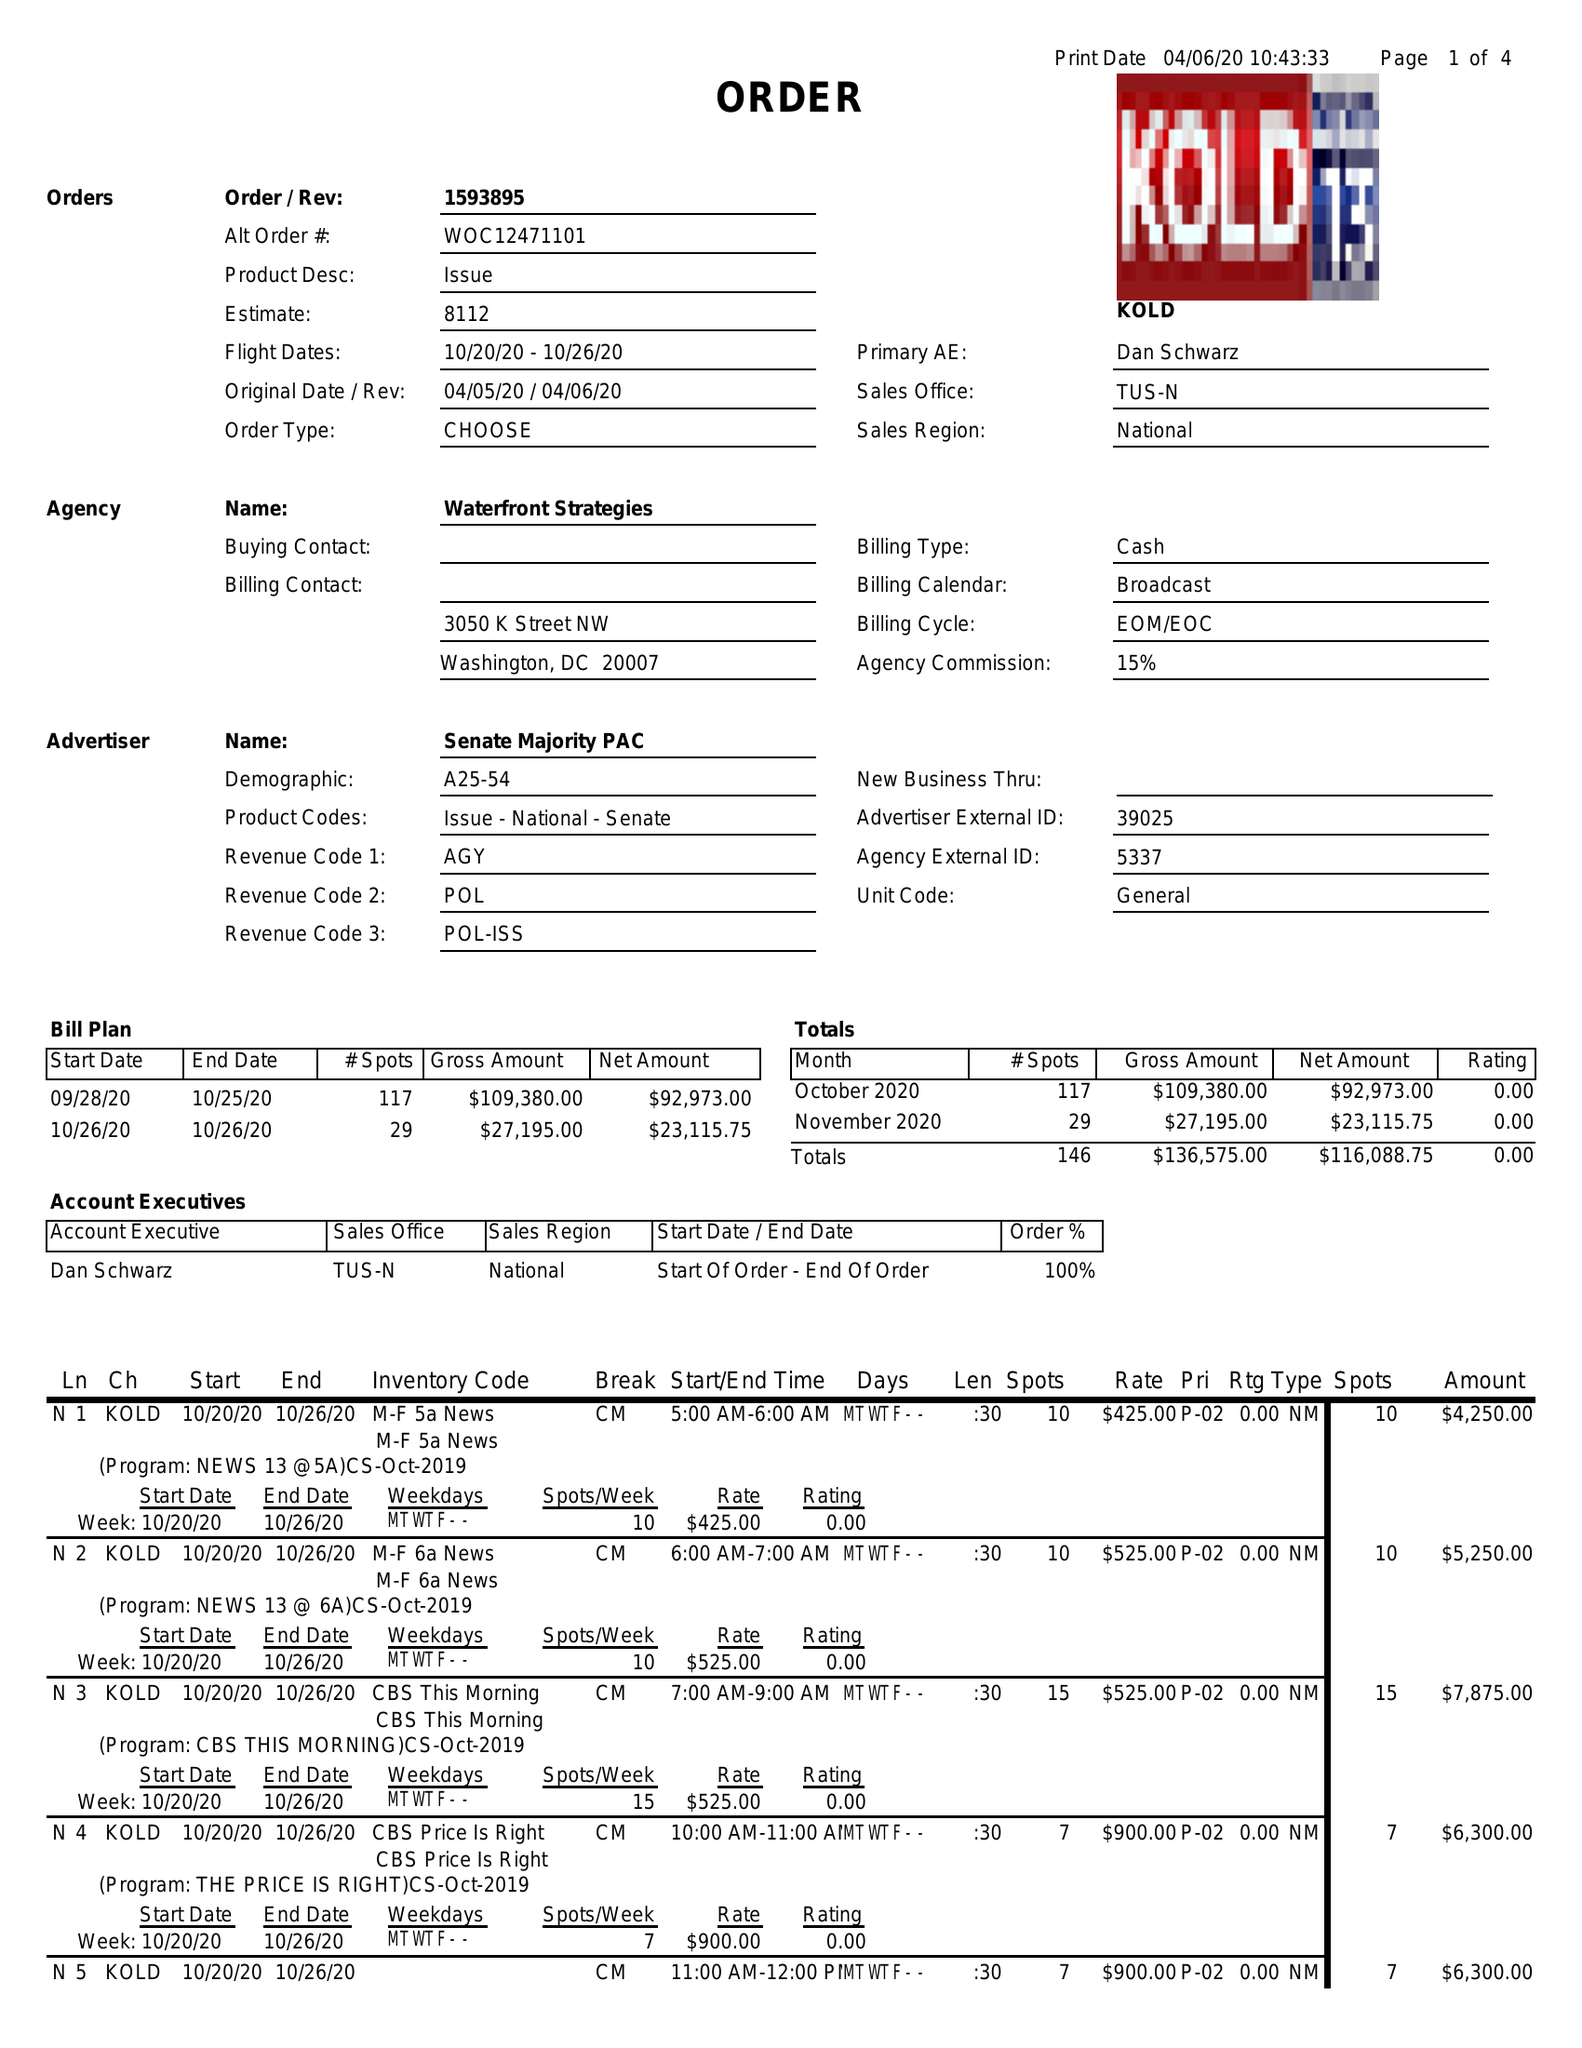What is the value for the flight_from?
Answer the question using a single word or phrase. 10/20/20 